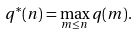Convert formula to latex. <formula><loc_0><loc_0><loc_500><loc_500>q ^ { * } ( n ) = \max _ { m \leq n } q ( m ) .</formula> 